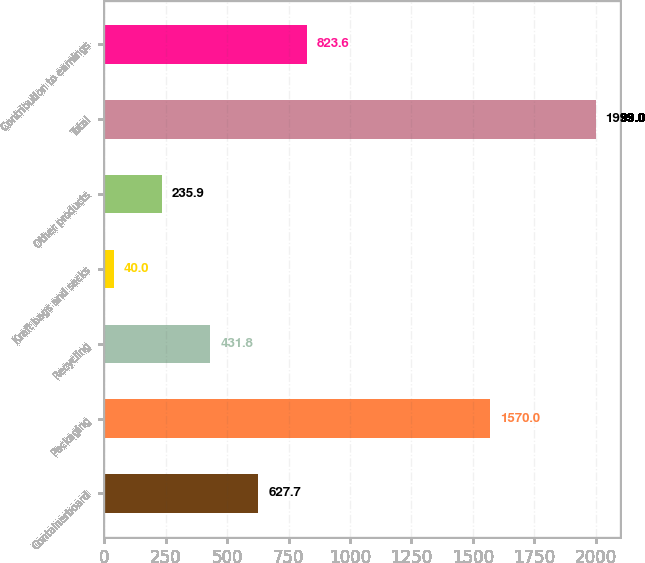Convert chart. <chart><loc_0><loc_0><loc_500><loc_500><bar_chart><fcel>Containerboard<fcel>Packaging<fcel>Recycling<fcel>Kraft bags and sacks<fcel>Other products<fcel>Total<fcel>Contribution to earnings<nl><fcel>627.7<fcel>1570<fcel>431.8<fcel>40<fcel>235.9<fcel>1999<fcel>823.6<nl></chart> 